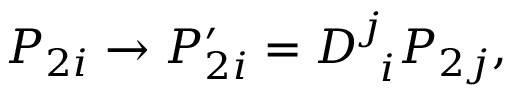Convert formula to latex. <formula><loc_0><loc_0><loc_500><loc_500>P _ { 2 i } \rightarrow P _ { 2 i } ^ { \prime } = D _ { \, i } ^ { j } P _ { 2 j } ,</formula> 